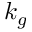<formula> <loc_0><loc_0><loc_500><loc_500>k _ { g }</formula> 